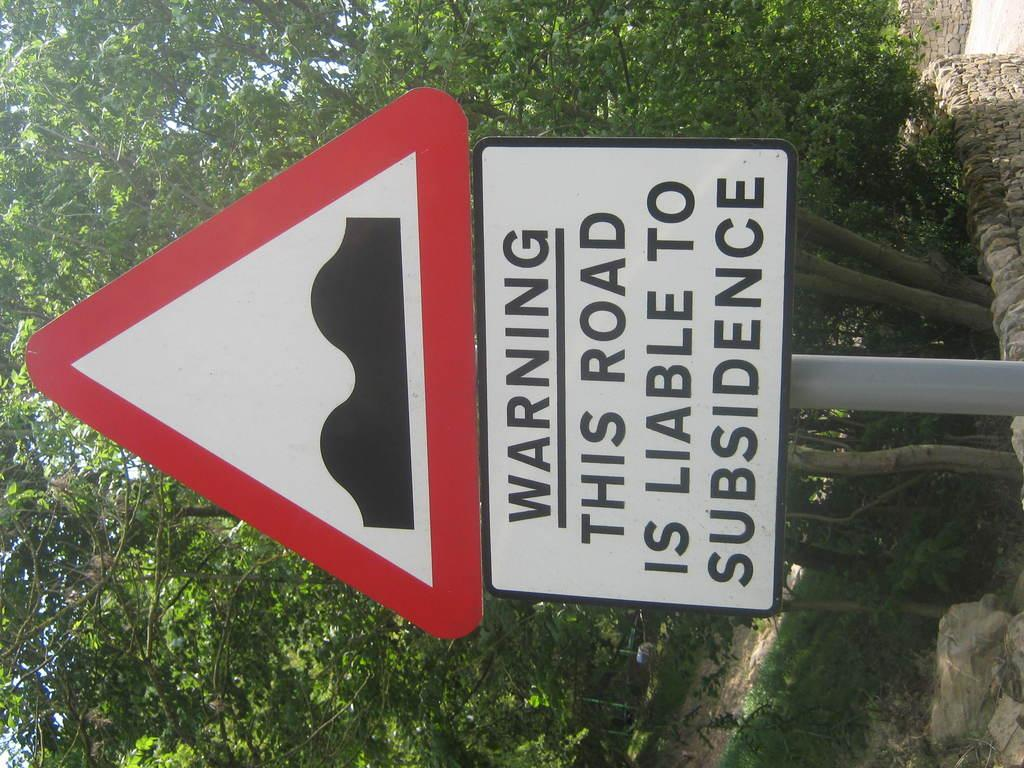What is present on the pole in the image? There is a sign board and another board with texts on it in the image. What can be seen on the boards? The sign board has information or advertisements, and there are texts written on the other board. What is visible in the background of the image? There are trees, grass on the ground, and walls in the background of the image. What type of meat can be seen hanging from the pole in the image? There is no meat present in the image; it features boards on a pole with texts and a sign. 